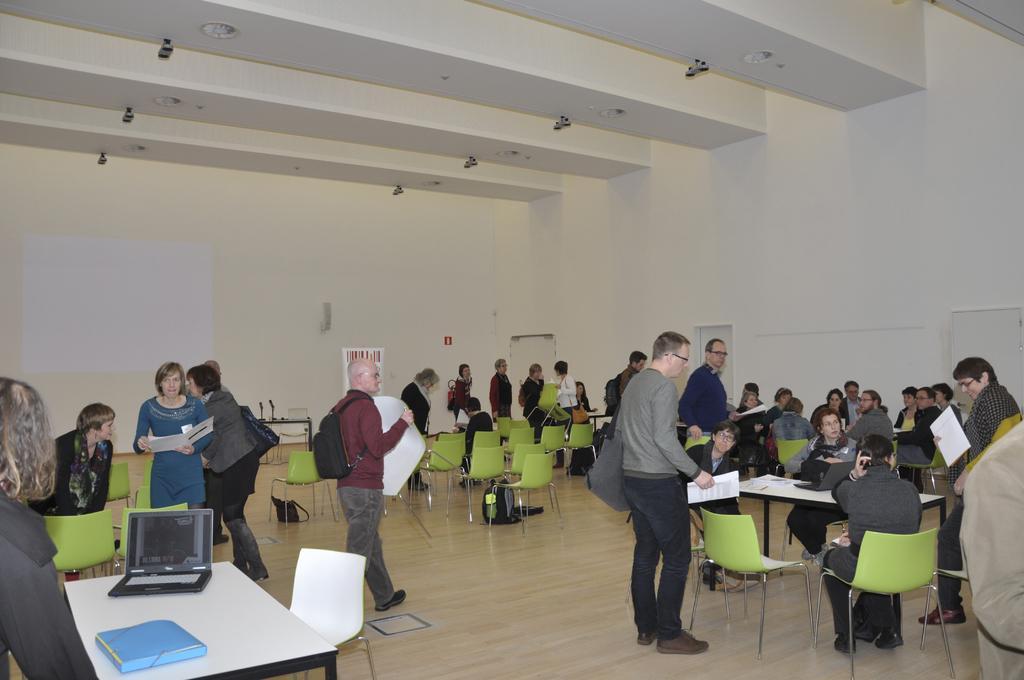Could you give a brief overview of what you see in this image? In this image, There is a floor which is in white color, There are some tables which are in white color, There are some chairs which are in green color, There are some people sitting on the chairs and there are some people standing and there is a wall which is in white color and in the top there is a roof which is in white color, and some lights fitted in the roof. 